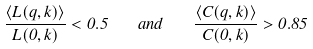<formula> <loc_0><loc_0><loc_500><loc_500>\frac { \left \langle L ( q , k ) \right \rangle } { L ( 0 , k ) } < 0 . 5 \quad a n d \quad \frac { \left \langle C ( q , k ) \right \rangle } { C ( 0 , k ) } > 0 . 8 5</formula> 